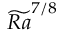Convert formula to latex. <formula><loc_0><loc_0><loc_500><loc_500>\widetilde { R a } ^ { 7 / 8 }</formula> 